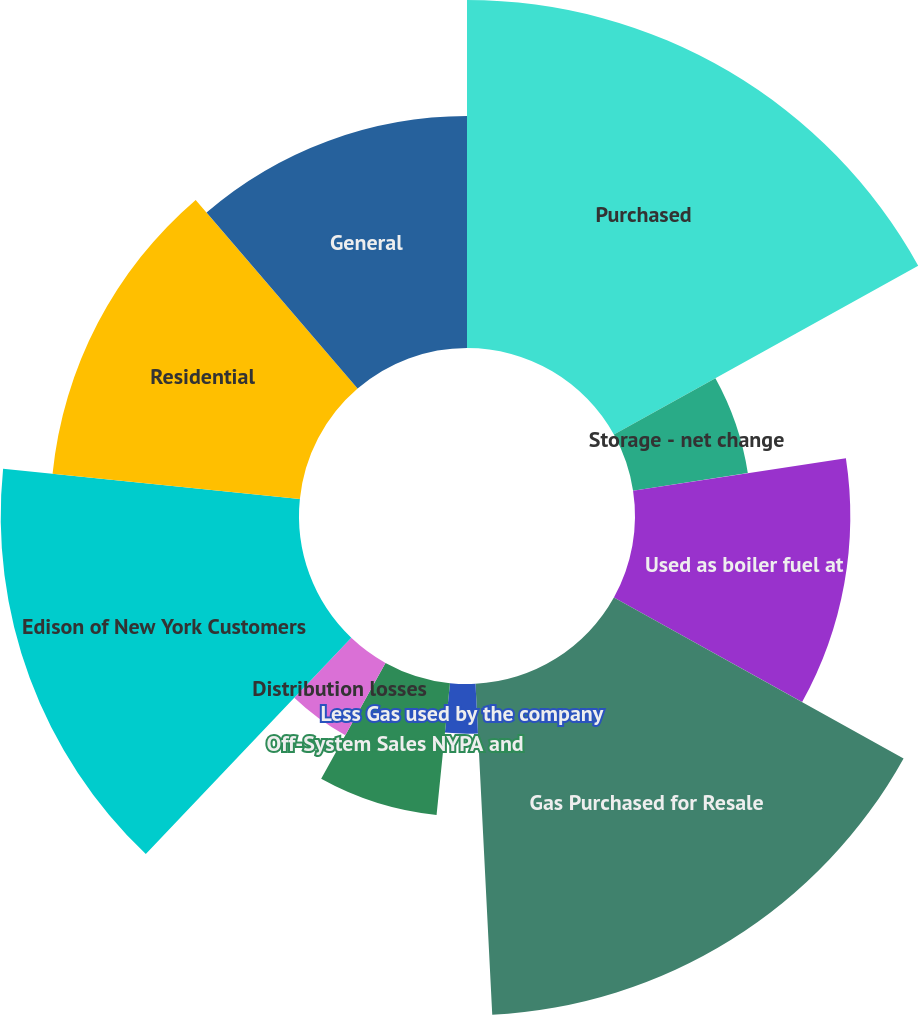Convert chart to OTSL. <chart><loc_0><loc_0><loc_500><loc_500><pie_chart><fcel>Purchased<fcel>Storage - net change<fcel>Used as boiler fuel at<fcel>Gas Purchased for Resale<fcel>Less Gas used by the company<fcel>Off-System Sales NYPA and<fcel>Distribution losses<fcel>Edison of New York Customers<fcel>Residential<fcel>General<nl><fcel>16.94%<fcel>5.65%<fcel>10.48%<fcel>16.13%<fcel>2.42%<fcel>6.45%<fcel>4.03%<fcel>14.52%<fcel>12.1%<fcel>11.29%<nl></chart> 